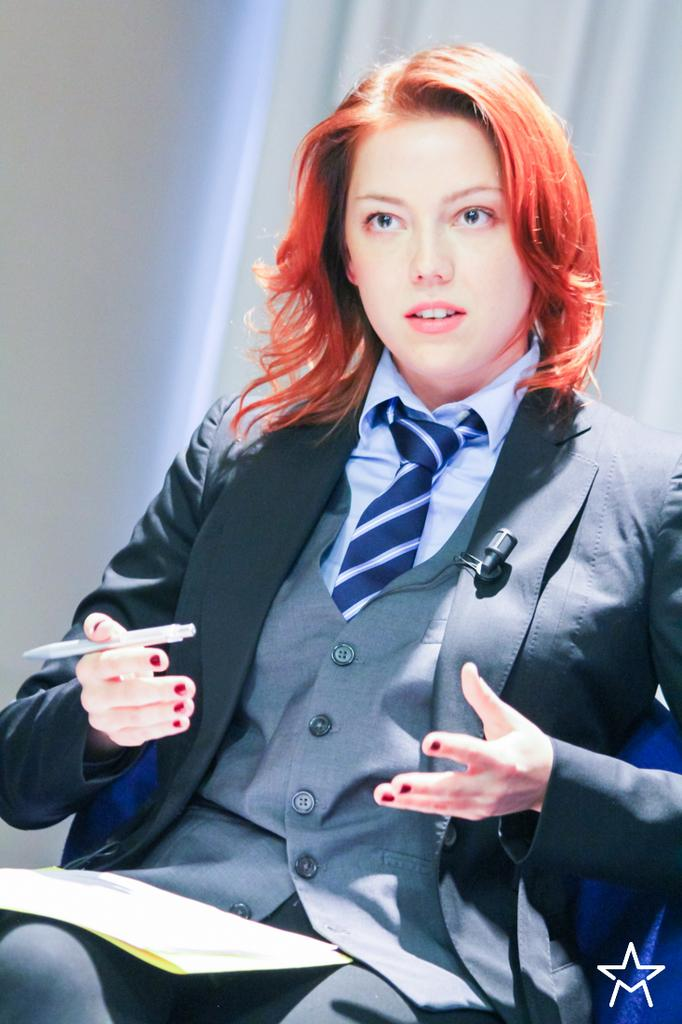Who is in the image? There is a woman in the image. What is the woman doing in the image? The woman is sitting on a chair and holding a pen. What is the woman holding in her lap? There are papers on the woman's lap. What can be seen in the background of the image? There is a wall and a white curtain in the background of the image. What type of root can be seen growing on the woman's chair in the image? There is no root growing on the woman's chair in the image. Is the woman holding a gun in the image? No, the woman is holding a pen, not a gun, in the image. 